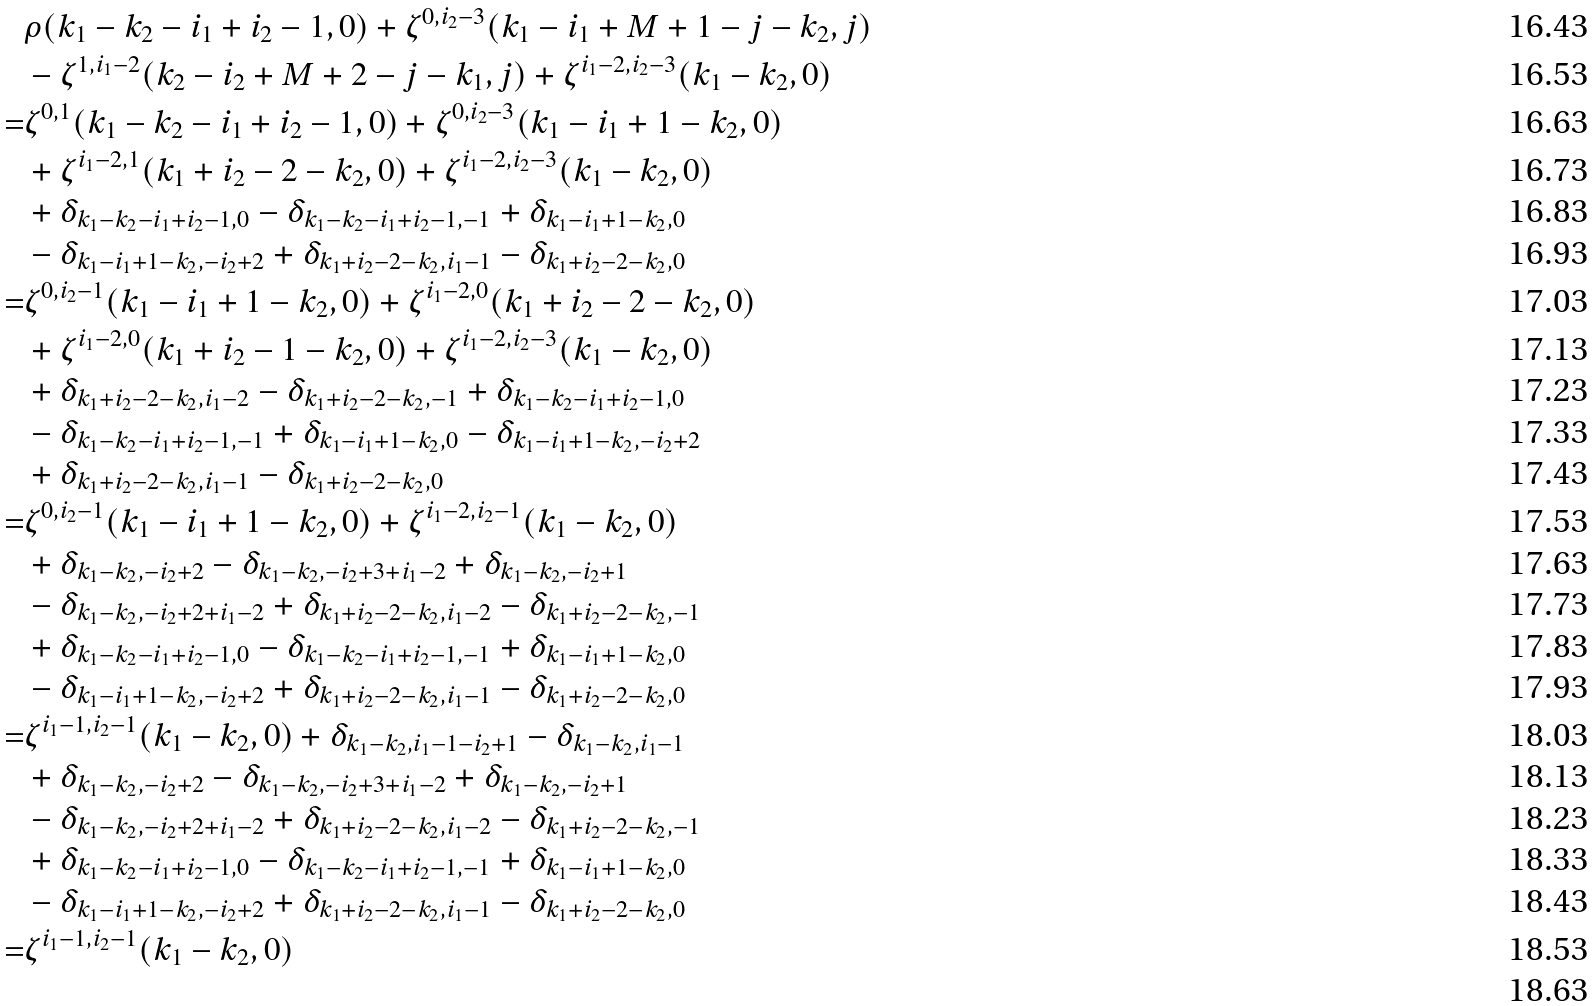Convert formula to latex. <formula><loc_0><loc_0><loc_500><loc_500>& \rho ( k _ { 1 } - k _ { 2 } - i _ { 1 } + i _ { 2 } - 1 , 0 ) + \zeta ^ { 0 , i _ { 2 } - 3 } ( k _ { 1 } - i _ { 1 } + M + 1 - j - k _ { 2 } , j ) \\ & - \zeta ^ { 1 , i _ { 1 } - 2 } ( k _ { 2 } - i _ { 2 } + M + 2 - j - k _ { 1 } , j ) + \zeta ^ { i _ { 1 } - 2 , i _ { 2 } - 3 } ( k _ { 1 } - k _ { 2 } , 0 ) \\ = & \zeta ^ { 0 , 1 } ( k _ { 1 } - k _ { 2 } - i _ { 1 } + i _ { 2 } - 1 , 0 ) + \zeta ^ { 0 , i _ { 2 } - 3 } ( k _ { 1 } - i _ { 1 } + 1 - k _ { 2 } , 0 ) \\ & + \zeta ^ { i _ { 1 } - 2 , 1 } ( k _ { 1 } + i _ { 2 } - 2 - k _ { 2 } , 0 ) + \zeta ^ { i _ { 1 } - 2 , i _ { 2 } - 3 } ( k _ { 1 } - k _ { 2 } , 0 ) \\ & + \delta _ { k _ { 1 } - k _ { 2 } - i _ { 1 } + i _ { 2 } - 1 , 0 } - \delta _ { k _ { 1 } - k _ { 2 } - i _ { 1 } + i _ { 2 } - 1 , - 1 } + \delta _ { k _ { 1 } - i _ { 1 } + 1 - k _ { 2 } , 0 } \\ & - \delta _ { k _ { 1 } - i _ { 1 } + 1 - k _ { 2 } , - i _ { 2 } + 2 } + \delta _ { k _ { 1 } + i _ { 2 } - 2 - k _ { 2 } , i _ { 1 } - 1 } - \delta _ { k _ { 1 } + i _ { 2 } - 2 - k _ { 2 } , 0 } \\ = & \zeta ^ { 0 , i _ { 2 } - 1 } ( k _ { 1 } - i _ { 1 } + 1 - k _ { 2 } , 0 ) + \zeta ^ { i _ { 1 } - 2 , 0 } ( k _ { 1 } + i _ { 2 } - 2 - k _ { 2 } , 0 ) \\ & + \zeta ^ { i _ { 1 } - 2 , 0 } ( k _ { 1 } + i _ { 2 } - 1 - k _ { 2 } , 0 ) + \zeta ^ { i _ { 1 } - 2 , i _ { 2 } - 3 } ( k _ { 1 } - k _ { 2 } , 0 ) \\ & + \delta _ { k _ { 1 } + i _ { 2 } - 2 - k _ { 2 } , i _ { 1 } - 2 } - \delta _ { k _ { 1 } + i _ { 2 } - 2 - k _ { 2 } , - 1 } + \delta _ { k _ { 1 } - k _ { 2 } - i _ { 1 } + i _ { 2 } - 1 , 0 } \\ & - \delta _ { k _ { 1 } - k _ { 2 } - i _ { 1 } + i _ { 2 } - 1 , - 1 } + \delta _ { k _ { 1 } - i _ { 1 } + 1 - k _ { 2 } , 0 } - \delta _ { k _ { 1 } - i _ { 1 } + 1 - k _ { 2 } , - i _ { 2 } + 2 } \\ & + \delta _ { k _ { 1 } + i _ { 2 } - 2 - k _ { 2 } , i _ { 1 } - 1 } - \delta _ { k _ { 1 } + i _ { 2 } - 2 - k _ { 2 } , 0 } \\ = & \zeta ^ { 0 , i _ { 2 } - 1 } ( k _ { 1 } - i _ { 1 } + 1 - k _ { 2 } , 0 ) + \zeta ^ { i _ { 1 } - 2 , i _ { 2 } - 1 } ( k _ { 1 } - k _ { 2 } , 0 ) \\ & + \delta _ { k _ { 1 } - k _ { 2 } , - i _ { 2 } + 2 } - \delta _ { k _ { 1 } - k _ { 2 } , - i _ { 2 } + 3 + i _ { 1 } - 2 } + \delta _ { k _ { 1 } - k _ { 2 } , - i _ { 2 } + 1 } \\ & - \delta _ { k _ { 1 } - k _ { 2 } , - i _ { 2 } + 2 + i _ { 1 } - 2 } + \delta _ { k _ { 1 } + i _ { 2 } - 2 - k _ { 2 } , i _ { 1 } - 2 } - \delta _ { k _ { 1 } + i _ { 2 } - 2 - k _ { 2 } , - 1 } \\ & + \delta _ { k _ { 1 } - k _ { 2 } - i _ { 1 } + i _ { 2 } - 1 , 0 } - \delta _ { k _ { 1 } - k _ { 2 } - i _ { 1 } + i _ { 2 } - 1 , - 1 } + \delta _ { k _ { 1 } - i _ { 1 } + 1 - k _ { 2 } , 0 } \\ & - \delta _ { k _ { 1 } - i _ { 1 } + 1 - k _ { 2 } , - i _ { 2 } + 2 } + \delta _ { k _ { 1 } + i _ { 2 } - 2 - k _ { 2 } , i _ { 1 } - 1 } - \delta _ { k _ { 1 } + i _ { 2 } - 2 - k _ { 2 } , 0 } \\ = & \zeta ^ { i _ { 1 } - 1 , i _ { 2 } - 1 } ( k _ { 1 } - k _ { 2 } , 0 ) + \delta _ { k _ { 1 } - k _ { 2 } , i _ { 1 } - 1 - i _ { 2 } + 1 } - \delta _ { k _ { 1 } - k _ { 2 } , i _ { 1 } - 1 } \\ & + \delta _ { k _ { 1 } - k _ { 2 } , - i _ { 2 } + 2 } - \delta _ { k _ { 1 } - k _ { 2 } , - i _ { 2 } + 3 + i _ { 1 } - 2 } + \delta _ { k _ { 1 } - k _ { 2 } , - i _ { 2 } + 1 } \\ & - \delta _ { k _ { 1 } - k _ { 2 } , - i _ { 2 } + 2 + i _ { 1 } - 2 } + \delta _ { k _ { 1 } + i _ { 2 } - 2 - k _ { 2 } , i _ { 1 } - 2 } - \delta _ { k _ { 1 } + i _ { 2 } - 2 - k _ { 2 } , - 1 } \\ & + \delta _ { k _ { 1 } - k _ { 2 } - i _ { 1 } + i _ { 2 } - 1 , 0 } - \delta _ { k _ { 1 } - k _ { 2 } - i _ { 1 } + i _ { 2 } - 1 , - 1 } + \delta _ { k _ { 1 } - i _ { 1 } + 1 - k _ { 2 } , 0 } \\ & - \delta _ { k _ { 1 } - i _ { 1 } + 1 - k _ { 2 } , - i _ { 2 } + 2 } + \delta _ { k _ { 1 } + i _ { 2 } - 2 - k _ { 2 } , i _ { 1 } - 1 } - \delta _ { k _ { 1 } + i _ { 2 } - 2 - k _ { 2 } , 0 } \\ = & \zeta ^ { i _ { 1 } - 1 , i _ { 2 } - 1 } ( k _ { 1 } - k _ { 2 } , 0 ) \\</formula> 